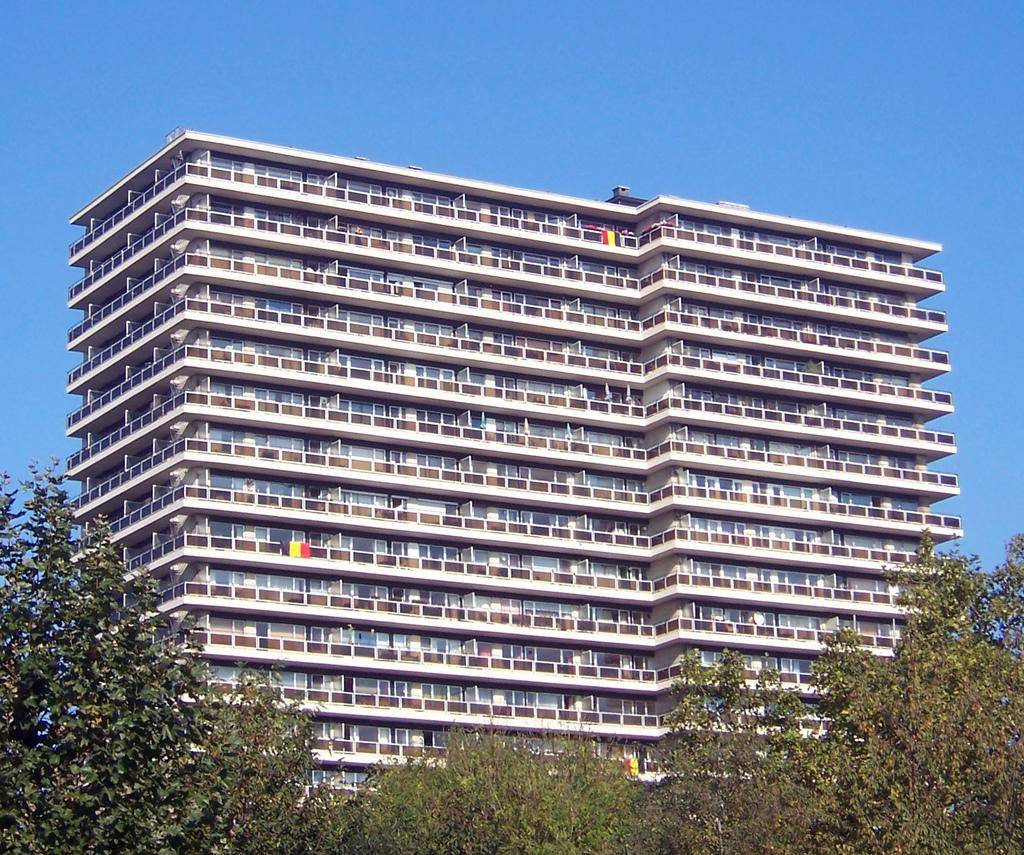What type of structure is present in the image? There is a building in the image. What are some features of the building? The building has walls, windows, and railings. What can be seen in the background of the image? The sky is visible in the background of the image. What type of vegetation is at the bottom of the image? There are trees at the bottom of the image. What type of juice can be seen flowing from the windows of the building in the image? There is no juice flowing from the windows of the building in the image. Can you see a zipper on any part of the building in the image? There is no zipper present on the building in the image. 